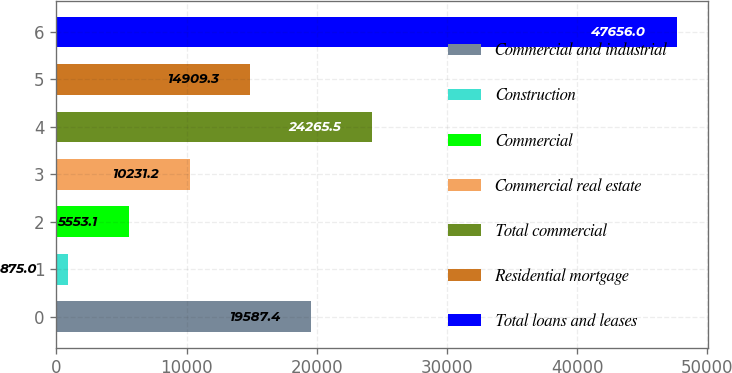<chart> <loc_0><loc_0><loc_500><loc_500><bar_chart><fcel>Commercial and industrial<fcel>Construction<fcel>Commercial<fcel>Commercial real estate<fcel>Total commercial<fcel>Residential mortgage<fcel>Total loans and leases<nl><fcel>19587.4<fcel>875<fcel>5553.1<fcel>10231.2<fcel>24265.5<fcel>14909.3<fcel>47656<nl></chart> 